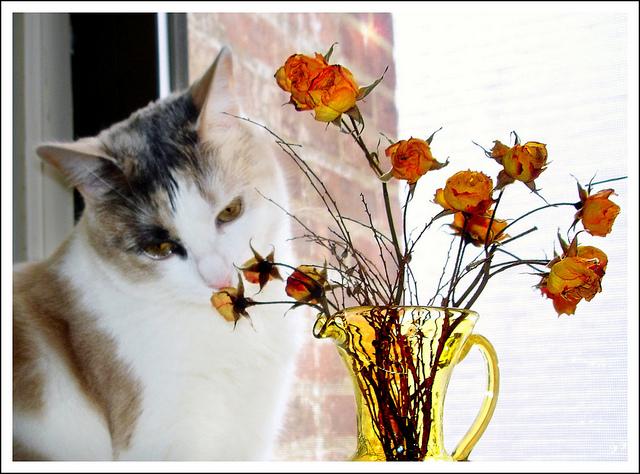What is the cat smelling?
Give a very brief answer. Flowers. What building material is visible through the window?
Quick response, please. Brick. What color is the flower container?
Quick response, please. Yellow. 